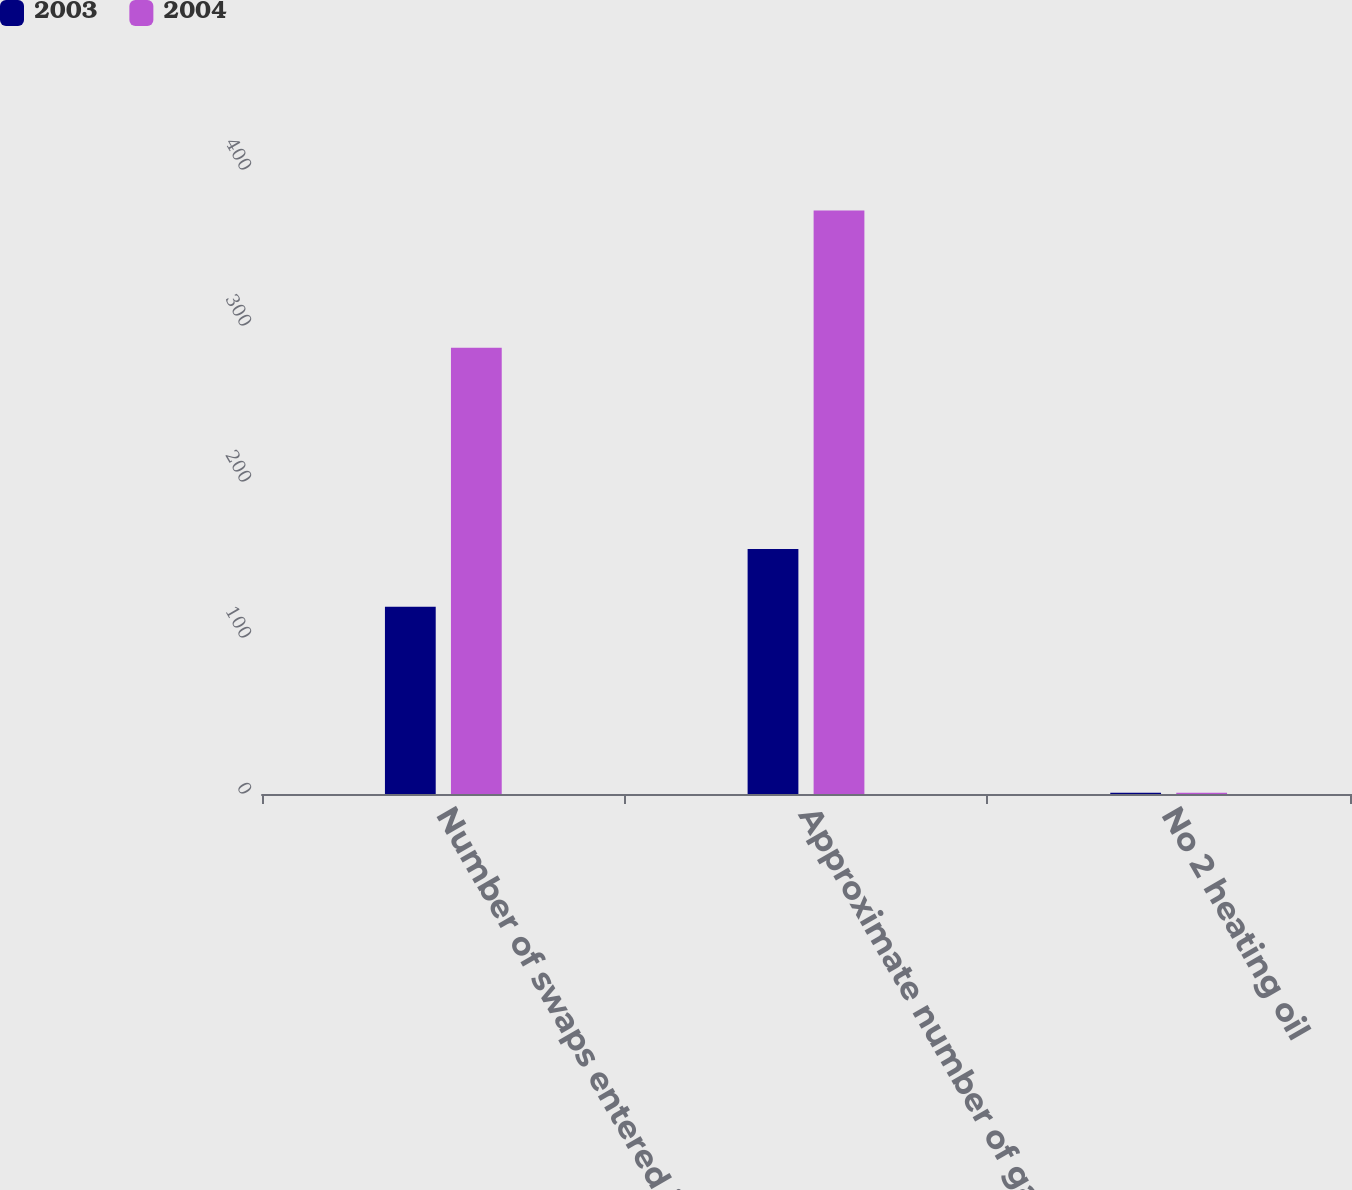Convert chart to OTSL. <chart><loc_0><loc_0><loc_500><loc_500><stacked_bar_chart><ecel><fcel>Number of swaps entered into<fcel>Approximate number of gallons<fcel>No 2 heating oil<nl><fcel>2003<fcel>120<fcel>157<fcel>0.86<nl><fcel>2004<fcel>286<fcel>374<fcel>0.76<nl></chart> 